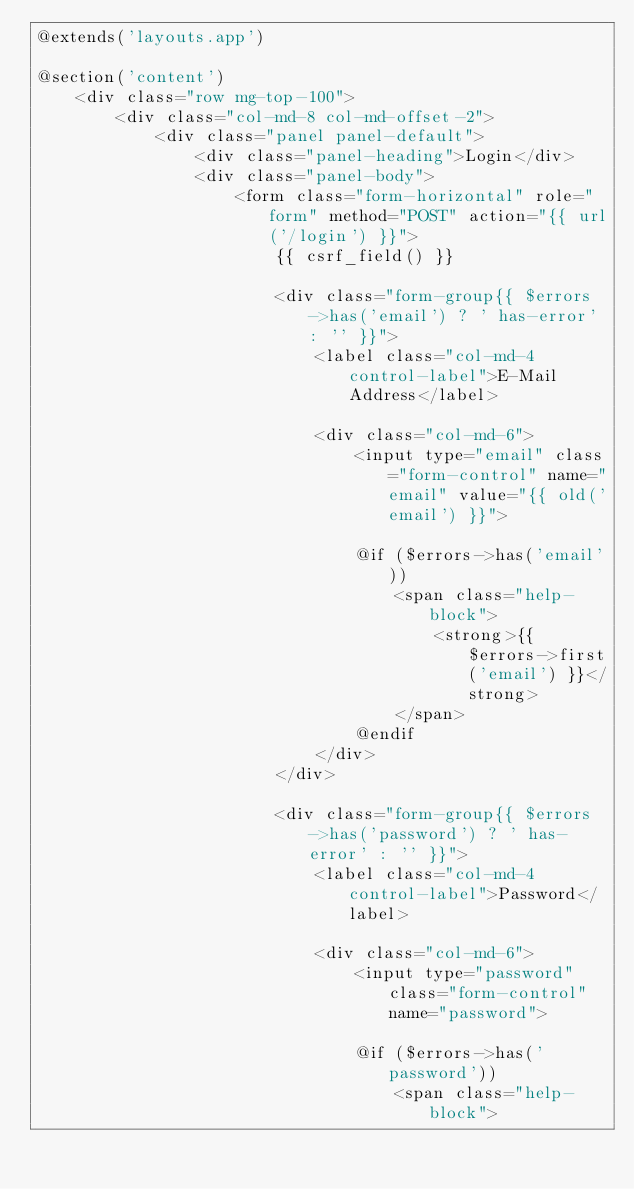Convert code to text. <code><loc_0><loc_0><loc_500><loc_500><_PHP_>@extends('layouts.app')

@section('content')
    <div class="row mg-top-100">
        <div class="col-md-8 col-md-offset-2">
            <div class="panel panel-default">
                <div class="panel-heading">Login</div>
                <div class="panel-body">
                    <form class="form-horizontal" role="form" method="POST" action="{{ url('/login') }}">
                        {{ csrf_field() }}

                        <div class="form-group{{ $errors->has('email') ? ' has-error' : '' }}">
                            <label class="col-md-4 control-label">E-Mail Address</label>

                            <div class="col-md-6">
                                <input type="email" class="form-control" name="email" value="{{ old('email') }}">

                                @if ($errors->has('email'))
                                    <span class="help-block">
                                        <strong>{{ $errors->first('email') }}</strong>
                                    </span>
                                @endif
                            </div>
                        </div>

                        <div class="form-group{{ $errors->has('password') ? ' has-error' : '' }}">
                            <label class="col-md-4 control-label">Password</label>

                            <div class="col-md-6">
                                <input type="password" class="form-control" name="password">

                                @if ($errors->has('password'))
                                    <span class="help-block"></code> 